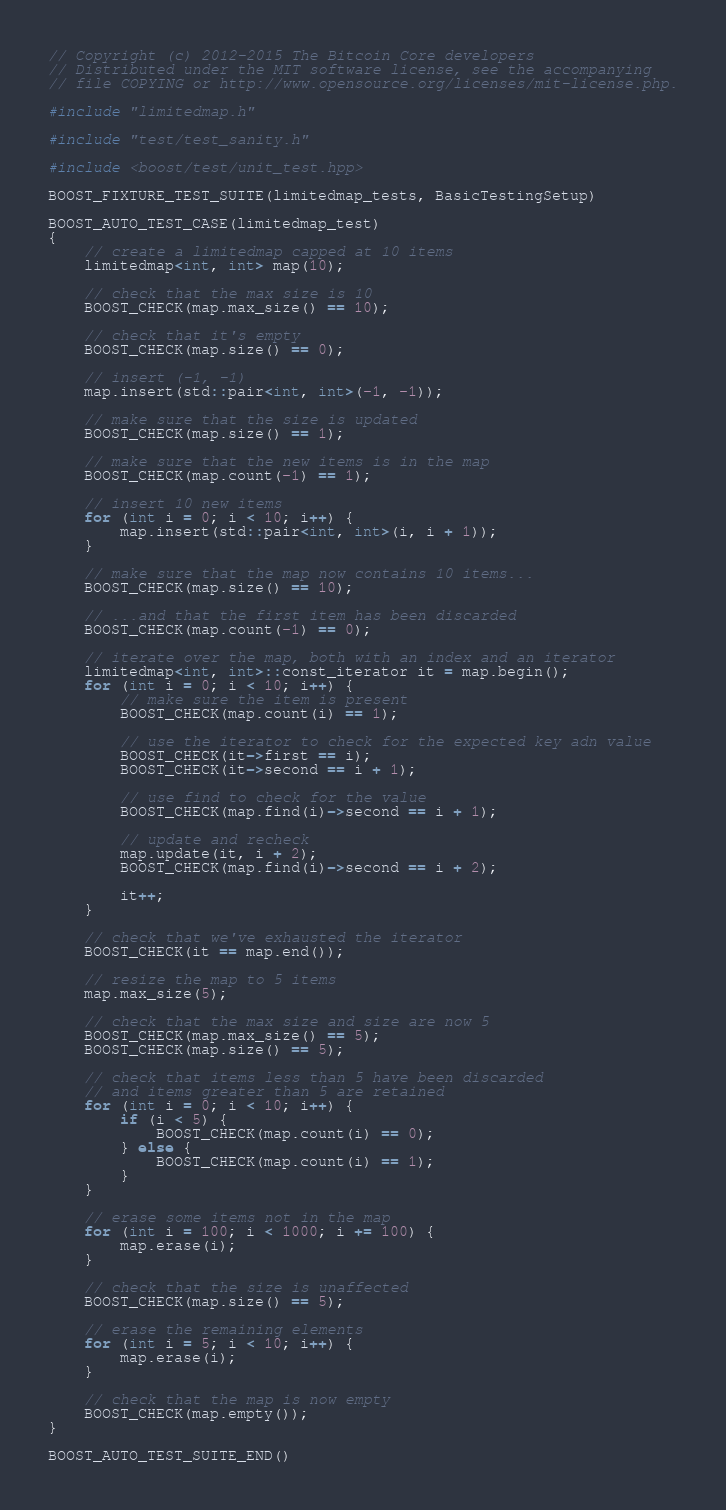Convert code to text. <code><loc_0><loc_0><loc_500><loc_500><_C++_>// Copyright (c) 2012-2015 The Bitcoin Core developers
// Distributed under the MIT software license, see the accompanying
// file COPYING or http://www.opensource.org/licenses/mit-license.php.

#include "limitedmap.h"

#include "test/test_sanity.h"

#include <boost/test/unit_test.hpp>

BOOST_FIXTURE_TEST_SUITE(limitedmap_tests, BasicTestingSetup)

BOOST_AUTO_TEST_CASE(limitedmap_test)
{
    // create a limitedmap capped at 10 items
    limitedmap<int, int> map(10);

    // check that the max size is 10
    BOOST_CHECK(map.max_size() == 10);

    // check that it's empty
    BOOST_CHECK(map.size() == 0);

    // insert (-1, -1)
    map.insert(std::pair<int, int>(-1, -1));

    // make sure that the size is updated
    BOOST_CHECK(map.size() == 1);

    // make sure that the new items is in the map
    BOOST_CHECK(map.count(-1) == 1);

    // insert 10 new items
    for (int i = 0; i < 10; i++) {
        map.insert(std::pair<int, int>(i, i + 1));
    }

    // make sure that the map now contains 10 items...
    BOOST_CHECK(map.size() == 10);

    // ...and that the first item has been discarded
    BOOST_CHECK(map.count(-1) == 0);

    // iterate over the map, both with an index and an iterator
    limitedmap<int, int>::const_iterator it = map.begin();
    for (int i = 0; i < 10; i++) {
        // make sure the item is present
        BOOST_CHECK(map.count(i) == 1);

        // use the iterator to check for the expected key adn value
        BOOST_CHECK(it->first == i);
        BOOST_CHECK(it->second == i + 1);
        
        // use find to check for the value
        BOOST_CHECK(map.find(i)->second == i + 1);
        
        // update and recheck
        map.update(it, i + 2);
        BOOST_CHECK(map.find(i)->second == i + 2);

        it++;
    }

    // check that we've exhausted the iterator
    BOOST_CHECK(it == map.end());

    // resize the map to 5 items
    map.max_size(5);

    // check that the max size and size are now 5
    BOOST_CHECK(map.max_size() == 5);
    BOOST_CHECK(map.size() == 5);

    // check that items less than 5 have been discarded
    // and items greater than 5 are retained
    for (int i = 0; i < 10; i++) {
        if (i < 5) {
            BOOST_CHECK(map.count(i) == 0);
        } else {
            BOOST_CHECK(map.count(i) == 1);
        }
    }

    // erase some items not in the map
    for (int i = 100; i < 1000; i += 100) {
        map.erase(i);
    }

    // check that the size is unaffected
    BOOST_CHECK(map.size() == 5);

    // erase the remaining elements
    for (int i = 5; i < 10; i++) {
        map.erase(i);
    }

    // check that the map is now empty
    BOOST_CHECK(map.empty());
}

BOOST_AUTO_TEST_SUITE_END()
</code> 